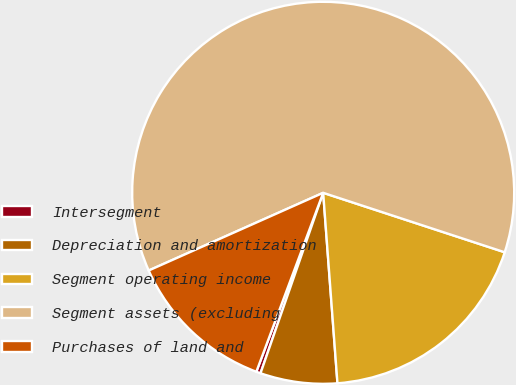<chart> <loc_0><loc_0><loc_500><loc_500><pie_chart><fcel>Intersegment<fcel>Depreciation and amortization<fcel>Segment operating income<fcel>Segment assets (excluding<fcel>Purchases of land and<nl><fcel>0.37%<fcel>6.51%<fcel>18.77%<fcel>61.7%<fcel>12.64%<nl></chart> 